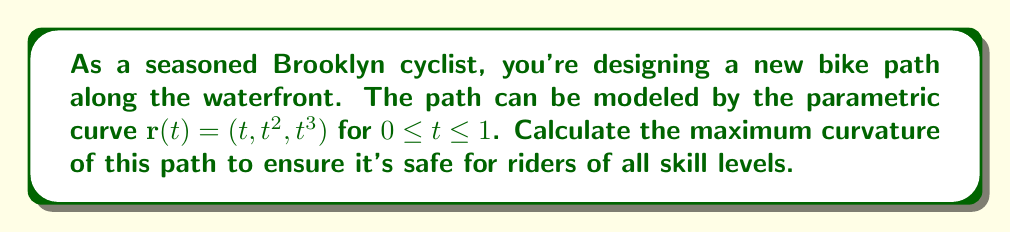Help me with this question. To find the maximum curvature of the bike path, we'll follow these steps:

1) First, we need to calculate the curvature $\kappa(t)$ using the formula:

   $$\kappa(t) = \frac{|\mathbf{r}'(t) \times \mathbf{r}''(t)|}{|\mathbf{r}'(t)|^3}$$

2) Let's find $\mathbf{r}'(t)$ and $\mathbf{r}''(t)$:
   
   $\mathbf{r}'(t) = (1, 2t, 3t^2)$
   $\mathbf{r}''(t) = (0, 2, 6t)$

3) Now, let's calculate the cross product $\mathbf{r}'(t) \times \mathbf{r}''(t)$:

   $$\mathbf{r}'(t) \times \mathbf{r}''(t) = \begin{vmatrix} 
   \mathbf{i} & \mathbf{j} & \mathbf{k} \\
   1 & 2t & 3t^2 \\
   0 & 2 & 6t
   \end{vmatrix} = (6t^2-6t^2)\mathbf{i} + (6t-0)\mathbf{j} + (2-4t)\mathbf{k} = 6t\mathbf{j} + (2-4t)\mathbf{k}$$

4) The magnitude of this cross product is:

   $$|\mathbf{r}'(t) \times \mathbf{r}''(t)| = \sqrt{(6t)^2 + (2-4t)^2} = 2\sqrt{9t^2 + (1-2t)^2}$$

5) Next, we need to calculate $|\mathbf{r}'(t)|^3$:

   $$|\mathbf{r}'(t)|^3 = (1^2 + (2t)^2 + (3t^2)^2)^{3/2} = (1 + 4t^2 + 9t^4)^{3/2}$$

6) Now we can write the curvature function:

   $$\kappa(t) = \frac{2\sqrt{9t^2 + (1-2t)^2}}{(1 + 4t^2 + 9t^4)^{3/2}}$$

7) To find the maximum curvature, we need to find the maximum value of this function on the interval $[0,1]$. This can be done by finding the critical points (where the derivative is zero or undefined) and checking the endpoints.

8) The derivative of $\kappa(t)$ is quite complex, so it's more practical to use numerical methods or graphing to find the maximum value.

9) Using a graphing calculator or computer software, we can plot $\kappa(t)$ for $0 \leq t \leq 1$ and find that the maximum value occurs at $t=0$.

10) Evaluating $\kappa(0)$:

    $$\kappa(0) = \frac{2\sqrt{0^2 + (1-0)^2}}{(1 + 0 + 0)^{3/2}} = 2$$

Therefore, the maximum curvature of the bike path is 2.
Answer: 2 